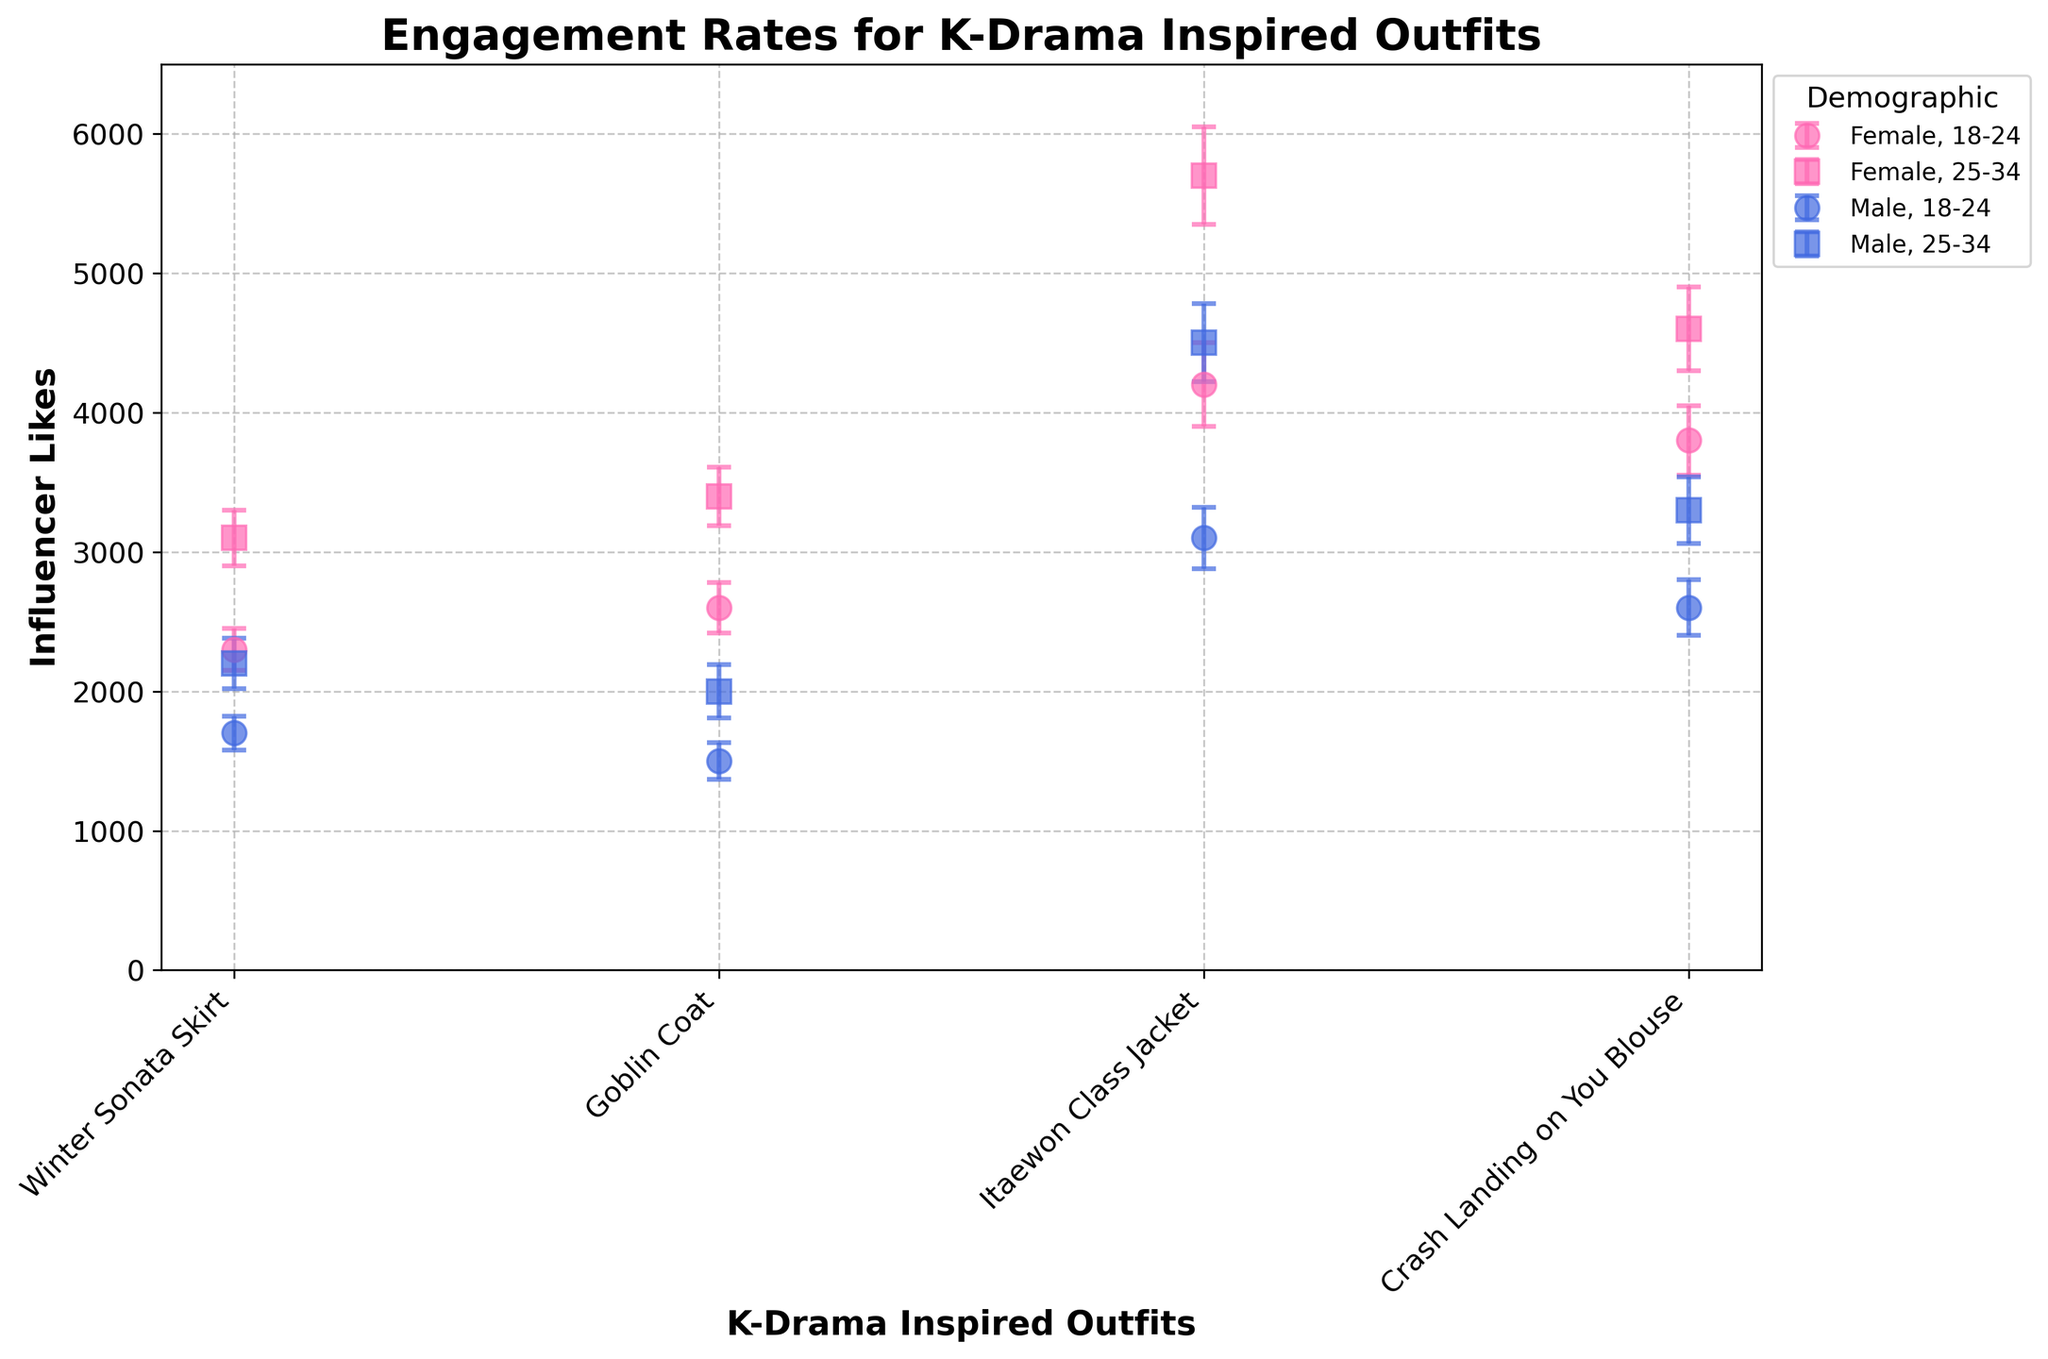What's the title of the figure? The title is usually placed on top of the figure, indicating the main focus of the plot. Here, the title states the subject of the engagement rates for Korean drama-inspired outfits.
Answer: Engagement Rates for K-Drama Inspired Outfits What does the y-axis represent? The y-axis indicates the metric being measured. In this figure, it represents the number of influencer likes for each outfit.
Answer: Influencer Likes Which age group and gender have the highest engagement for the 'Itaewon Class Jacket'? To answer this, locate the data points corresponding to 'Itaewon Class Jacket' and compare the y-values. The highest engagement will have the highest y-value. The 'Itaewon Class Jacket' engagement is highest for 25-34 Female.
Answer: 25-34 Female Which outfit has the lowest engagement among males aged 18-24? Check the outfits linked to the 18-24 Male group, and identify the one with the lowest y-value (likes). The 'Goblin Coat' has the lowest engagement in this demographic.
Answer: Goblin Coat What is the difference in influencer likes between the 'Winter Sonata Skirt' for 18-24 females and males? Subtract the number of likes for 18-24 males from that for 18-24 females for the 'Winter Sonata Skirt'. The likes are 2300 (female) and 1700 (male), so the difference is 2300 - 1700 = 600.
Answer: 600 What are the colors used to represent male and female groups? Refer to the color of the markers corresponding to male and female groups. Males are represented in blue and females in pink.
Answer: Blue and Pink Which outfit among females aged 25-34 shows the maximum variability in interactions? Look for the error bar lengths (indicating variability) among 25-34 females. The 'Itaewon Class Jacket' has the highest error bar of 350.
Answer: Itaewon Class Jacket For 'Crash Landing on You Blouse,' compare the influencer likes of 18-24 females and 25-34 females. Which group has more likes, and by how much? Compare the y-values (likes) for 'Crash Landing on You Blouse' for both groups. For 18-24 females, it's 3800, and for 25-34 females, it's 4600. The difference is 4600 - 3800 = 800, favoring the 25-34 females group.
Answer: 25-34 females, 800 Which outfit has the least variability in influencer likes for males aged 25-34? Examine the error bars for each outfit in the 25-34 male category. The 'Crash Landing on You Blouse' has the smallest error bar (240).
Answer: Crash Landing on You Blouse 